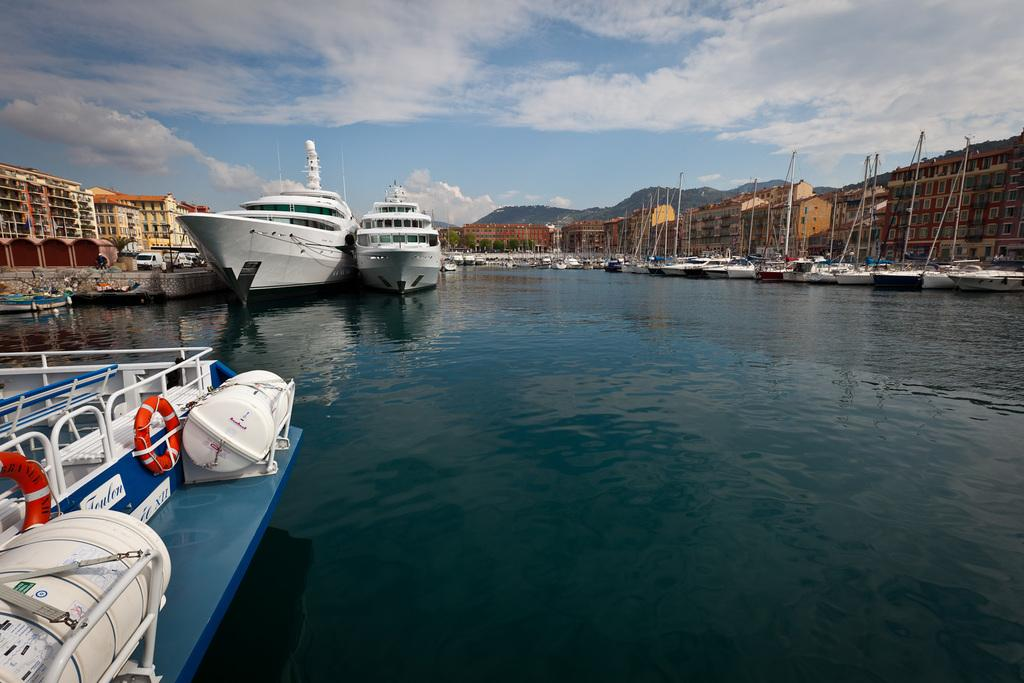What is located in the middle of the lake in the image? There are ships in the middle of the lake in the image. What can be seen on either side of the lake? There are buildings on either side of the lake in the image. What is visible in the sky in the image? The sky is visible in the image. What can be observed in the sky? Clouds are present in the sky. Where is the boot located in the image? There is no boot present in the image. What type of bed can be seen in the image? There is no bed present in the image. 